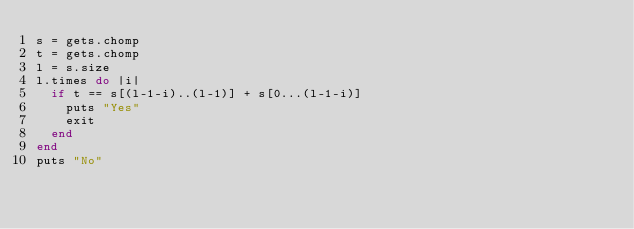Convert code to text. <code><loc_0><loc_0><loc_500><loc_500><_Ruby_>s = gets.chomp
t = gets.chomp
l = s.size
l.times do |i|
  if t == s[(l-1-i)..(l-1)] + s[0...(l-1-i)]
    puts "Yes"
    exit
  end
end
puts "No"</code> 